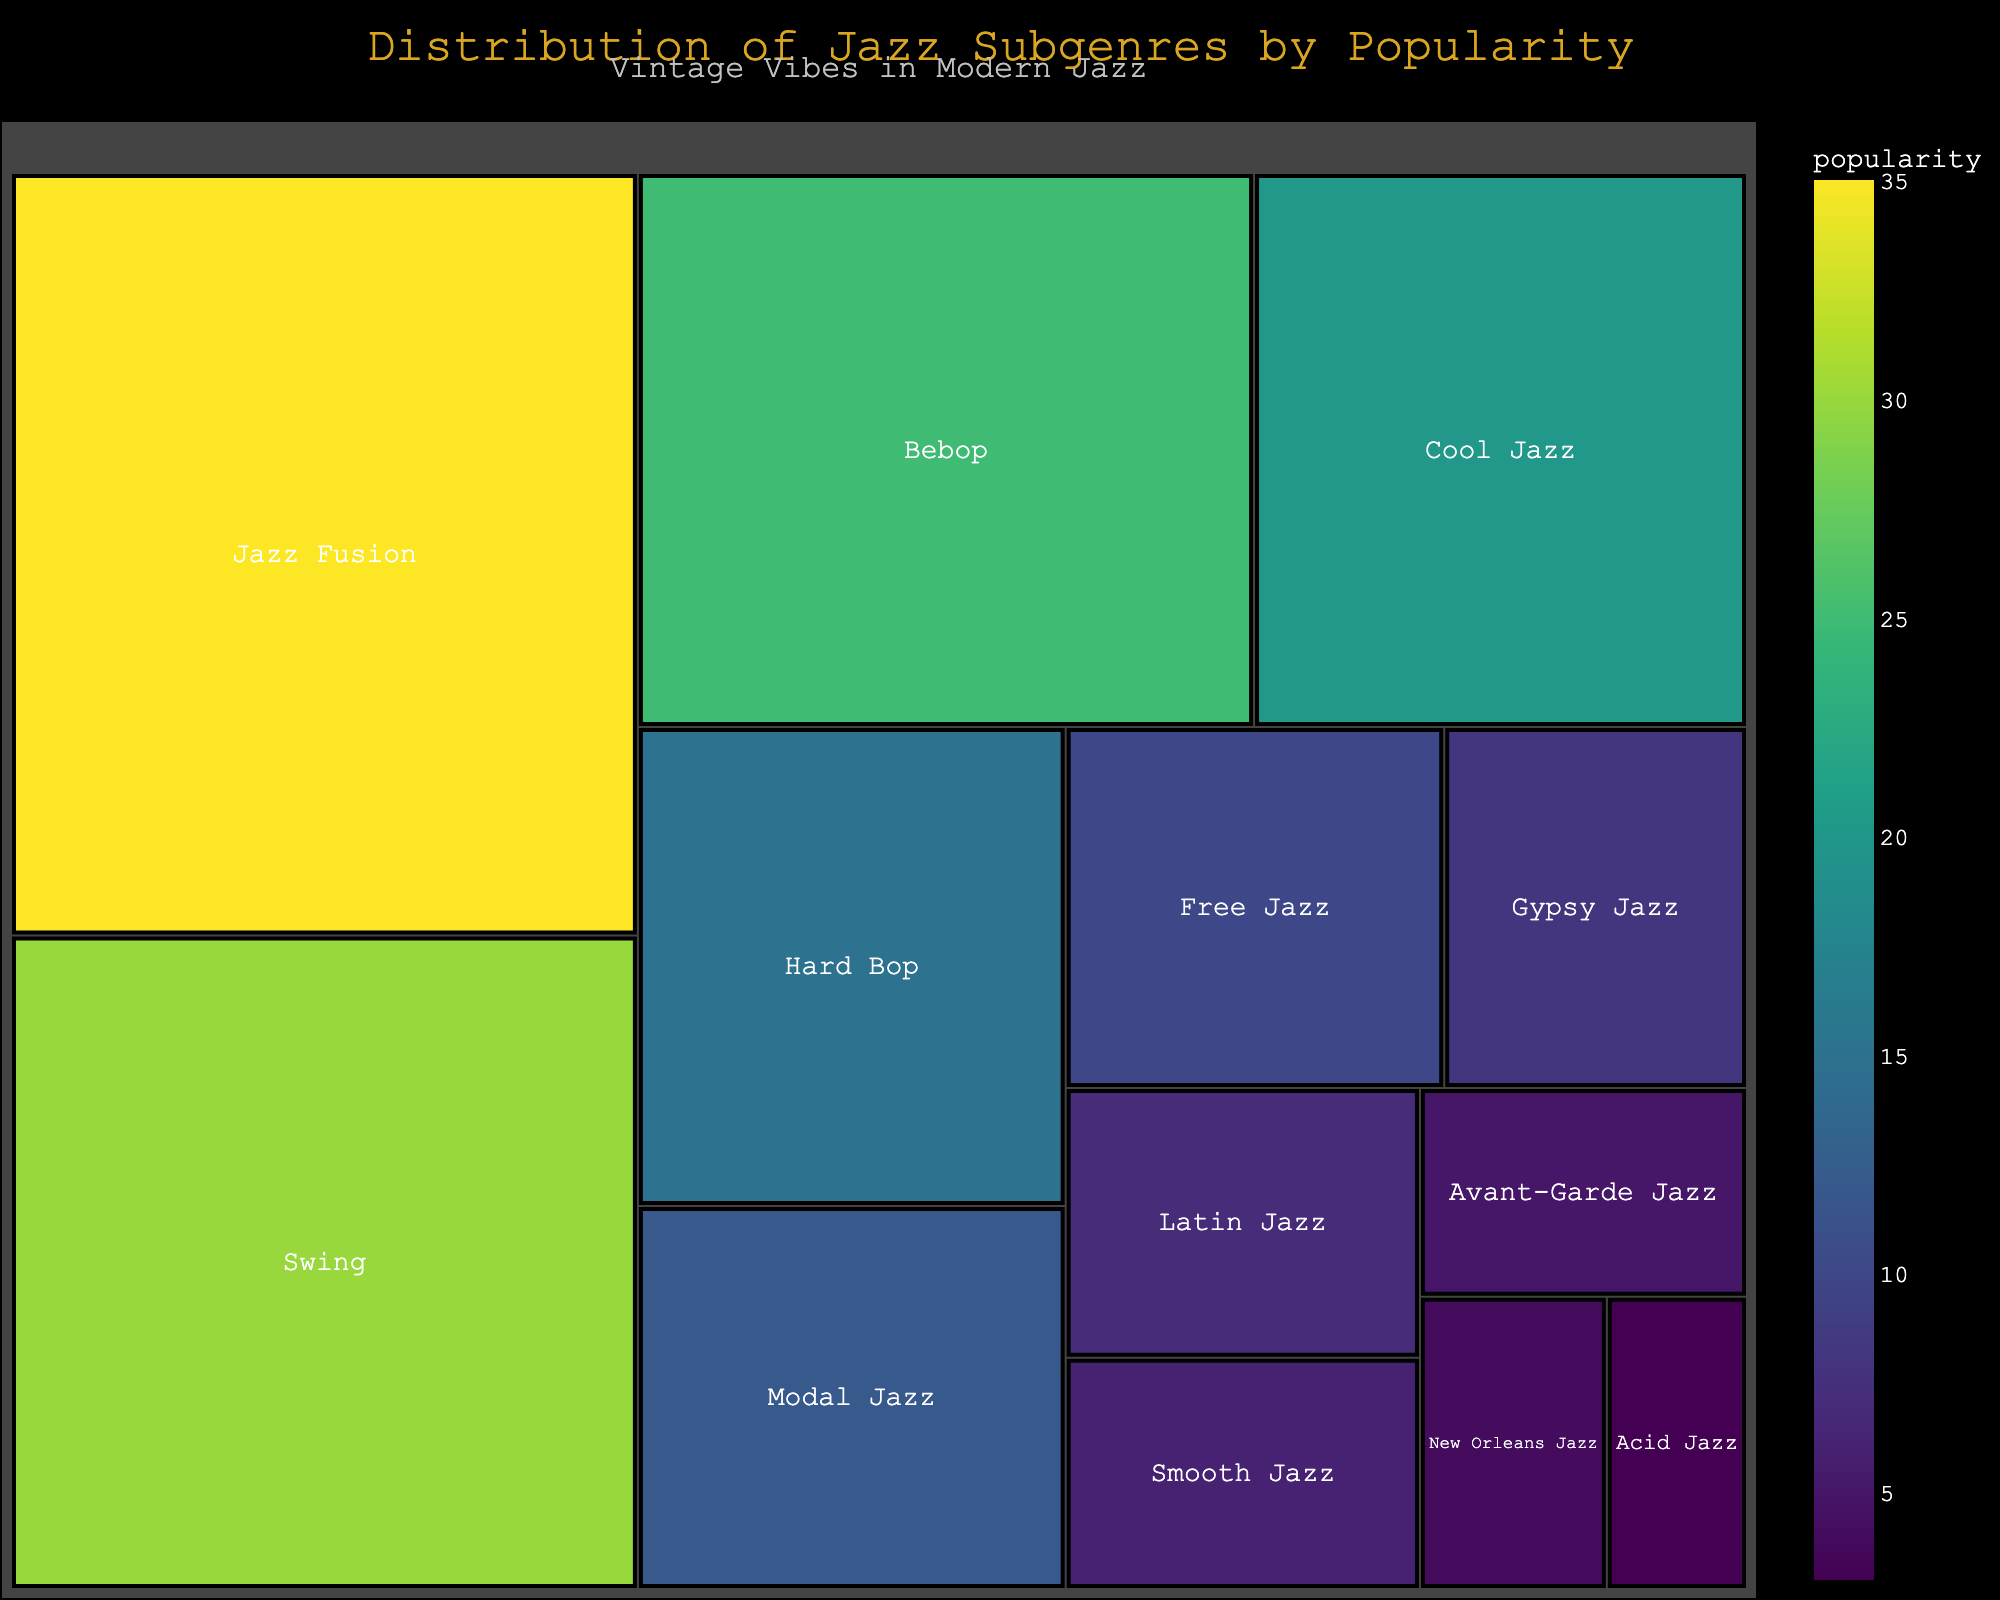What is the title of the treemap? The title of the treemap is displayed at the top of the figure, often in a larger font for prominence.
Answer: Distribution of Jazz Subgenres by Popularity Which jazz subgenre has the highest popularity? To find the jazz subgenre with the highest popularity, look for the largest area on the treemap with the highest value labeled.
Answer: Jazz Fusion What color represents the least popular subgenre? In the treemap, less popular subgenres are often shown in lighter colors on a Viridis scale. Look for the lightest-colored segment.
Answer: Pale yellow (corresponding to Acid Jazz) How much more popular is Swing compared to Bebop? Locate the areas for Swing and Bebop and note their popularity values (30 and 25). Subtract the popularity of Bebop from Swing. 30 - 25 = 5
Answer: 5 Which subgenre is immediately less popular than Bebop? Find the popularity of Bebop (25). The next less popular subgenre will have the closest lower value. This is Cool Jazz with a popularity of 20.
Answer: Cool Jazz What is the combined popularity of all subgenres with popularity less than 10? Sum the popularity values of Free Jazz (10), Gypsy Jazz (8), Latin Jazz (7), Smooth Jazz (6), Avant-Garde Jazz (5), New Orleans Jazz (4), Acid Jazz (3). 10 + 8 + 7 + 6 + 5 + 4 + 3 = 43
Answer: 43 How does Hard Bop's popularity compare to that of Cool Jazz? Consider the popularity values of both subgenres: Hard Bop (15) and Cool Jazz (20). Compare these values to determine which is higher.
Answer: Cool Jazz is more popular Which two subgenres combined make up exactly 45 in popularity? Check combinations of subgenres from the list to find a pair that sum to 45. Jazz Fusion (35) + Latin Jazz (7) + Acid Jazz (3) = 45
Answer: Jazz Fusion and Latin Jazz and Acid Jazz What is the average popularity of all subgenres? Sum the popularity of all subgenres and divide by the number of subgenres. (35 + 30 + 25 + 20 + 15 + 12 + 10 + 8 + 7 + 6 + 5 + 4 + 3) / 13. The sum is 180. 180 / 13 ≈ 13.85
Answer: 13.85 What does the subtitle say in the treemap? Locate the subtitle text appearing below the main title, usually in smaller and less prominent font.
Answer: Vintage Vibes in Modern Jazz 